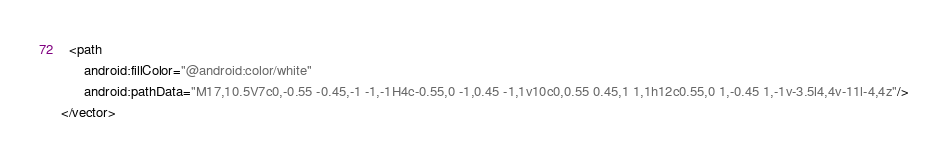<code> <loc_0><loc_0><loc_500><loc_500><_XML_>  <path
      android:fillColor="@android:color/white"
      android:pathData="M17,10.5V7c0,-0.55 -0.45,-1 -1,-1H4c-0.55,0 -1,0.45 -1,1v10c0,0.55 0.45,1 1,1h12c0.55,0 1,-0.45 1,-1v-3.5l4,4v-11l-4,4z"/>
</vector>
</code> 